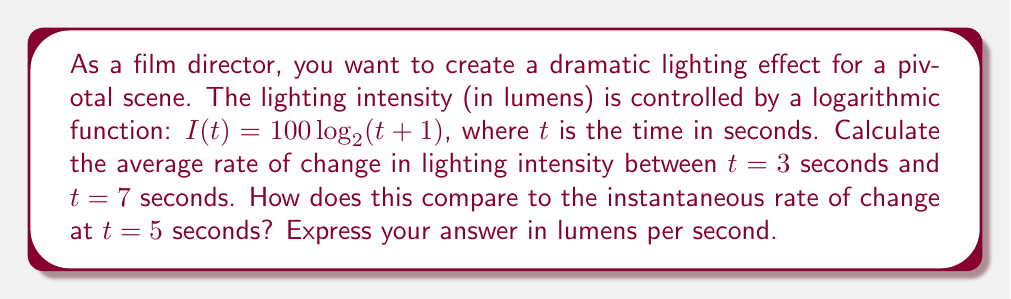Show me your answer to this math problem. To solve this problem, we'll follow these steps:

1. Calculate the average rate of change:
   The average rate of change is given by the formula:
   $$\text{Average rate of change} = \frac{I(7) - I(3)}{7 - 3}$$

   First, let's calculate $I(3)$ and $I(7)$:
   $$I(3) = 100 \log_2(3+1) = 100 \log_2(4) = 200$$
   $$I(7) = 100 \log_2(7+1) = 100 \log_2(8) = 300$$

   Now, we can calculate the average rate of change:
   $$\text{Average rate of change} = \frac{300 - 200}{7 - 3} = \frac{100}{4} = 25 \text{ lumens/second}$$

2. Calculate the instantaneous rate of change:
   The instantaneous rate of change is the derivative of the function at $t=5$.
   First, let's find the derivative of $I(t)$:
   $$I'(t) = \frac{d}{dt}[100 \log_2(t+1)] = \frac{100}{(t+1)\ln(2)}$$

   Now, we can evaluate this at $t=5$:
   $$I'(5) = \frac{100}{(5+1)\ln(2)} \approx 24.08 \text{ lumens/second}$$

3. Compare the two rates:
   The average rate of change (25 lumens/second) is slightly higher than the instantaneous rate of change at $t=5$ (24.08 lumens/second). This indicates that the lighting intensity is increasing at a decreasing rate, which is consistent with the logarithmic nature of the function.
Answer: The average rate of change between $t=3$ and $t=7$ is 25 lumens/second. The instantaneous rate of change at $t=5$ is approximately 24.08 lumens/second. The average rate of change is slightly higher than the instantaneous rate of change, indicating a decreasing rate of intensity increase over time. 